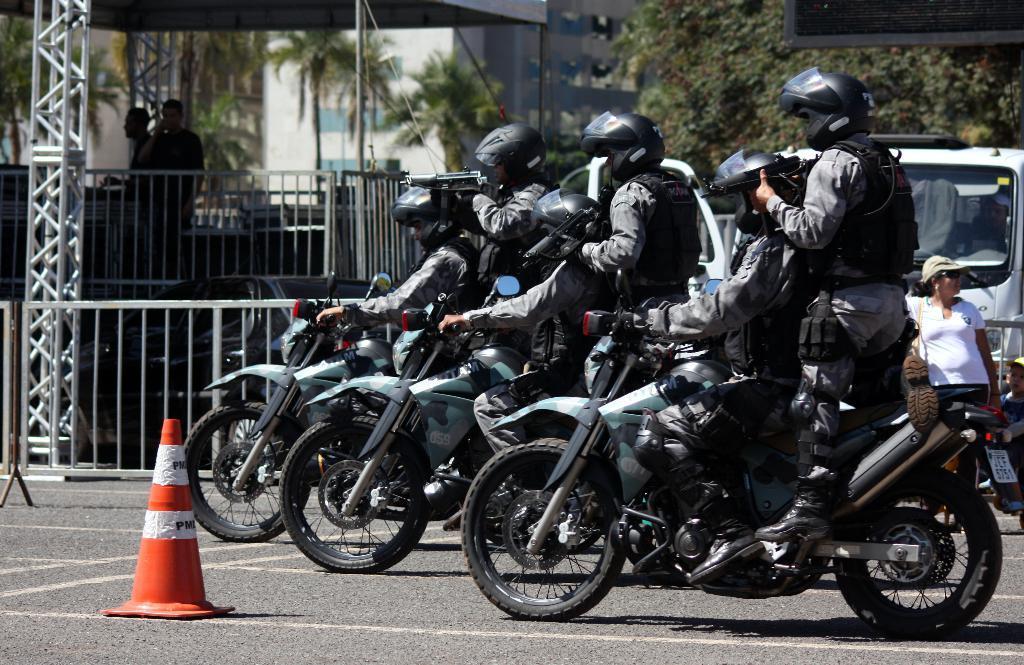Can you describe this image briefly? In this image we can see a few people riding the vehicle and behind them we can see a few people standing and holding the weapons, near that we can see the metal poles, trees, in the background we can see the buildings. 